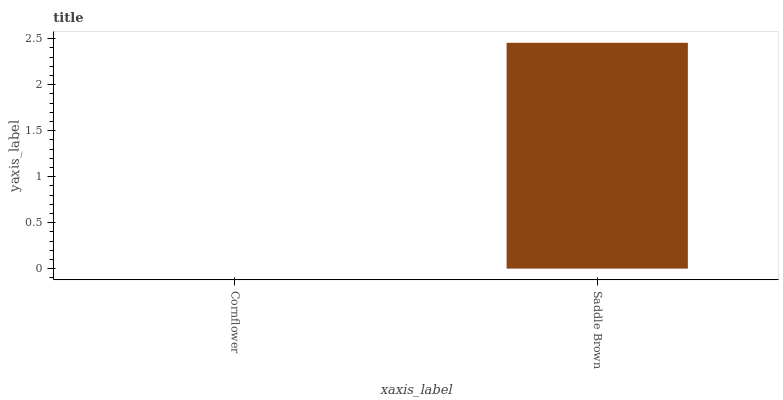Is Cornflower the minimum?
Answer yes or no. Yes. Is Saddle Brown the maximum?
Answer yes or no. Yes. Is Saddle Brown the minimum?
Answer yes or no. No. Is Saddle Brown greater than Cornflower?
Answer yes or no. Yes. Is Cornflower less than Saddle Brown?
Answer yes or no. Yes. Is Cornflower greater than Saddle Brown?
Answer yes or no. No. Is Saddle Brown less than Cornflower?
Answer yes or no. No. Is Saddle Brown the high median?
Answer yes or no. Yes. Is Cornflower the low median?
Answer yes or no. Yes. Is Cornflower the high median?
Answer yes or no. No. Is Saddle Brown the low median?
Answer yes or no. No. 